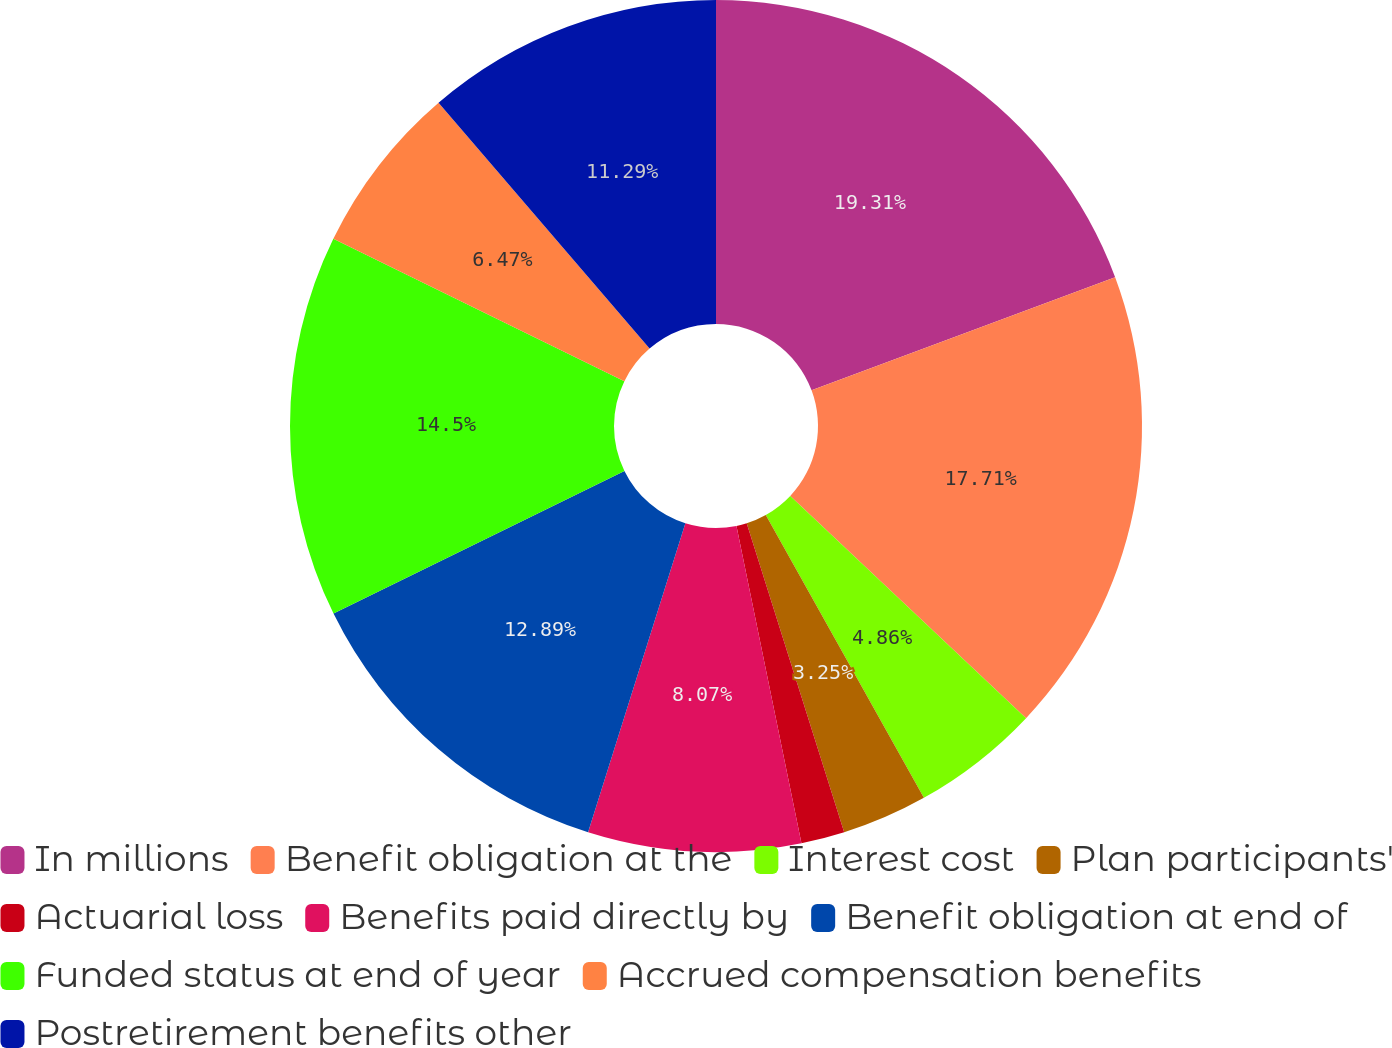Convert chart to OTSL. <chart><loc_0><loc_0><loc_500><loc_500><pie_chart><fcel>In millions<fcel>Benefit obligation at the<fcel>Interest cost<fcel>Plan participants'<fcel>Actuarial loss<fcel>Benefits paid directly by<fcel>Benefit obligation at end of<fcel>Funded status at end of year<fcel>Accrued compensation benefits<fcel>Postretirement benefits other<nl><fcel>19.32%<fcel>17.71%<fcel>4.86%<fcel>3.25%<fcel>1.65%<fcel>8.07%<fcel>12.89%<fcel>14.5%<fcel>6.47%<fcel>11.29%<nl></chart> 